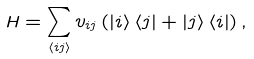Convert formula to latex. <formula><loc_0><loc_0><loc_500><loc_500>H = \sum _ { \left < i j \right > } v _ { i j } \left ( \left | i \right > \left < j \right | + \left | j \right > \left < i \right | \right ) ,</formula> 